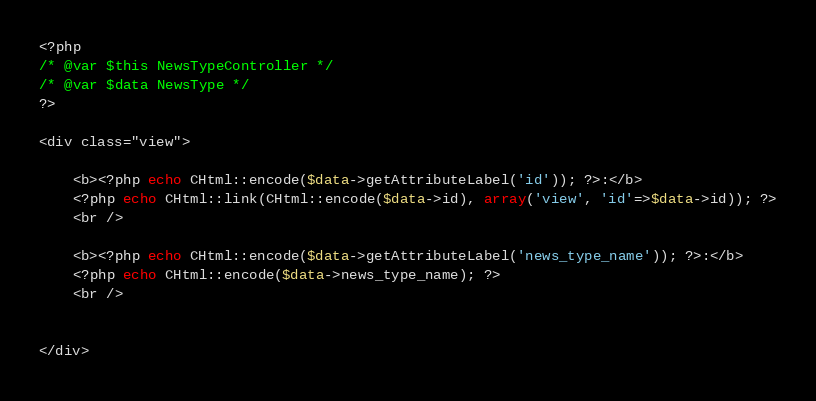<code> <loc_0><loc_0><loc_500><loc_500><_PHP_><?php
/* @var $this NewsTypeController */
/* @var $data NewsType */
?>

<div class="view">

	<b><?php echo CHtml::encode($data->getAttributeLabel('id')); ?>:</b>
	<?php echo CHtml::link(CHtml::encode($data->id), array('view', 'id'=>$data->id)); ?>
	<br />

	<b><?php echo CHtml::encode($data->getAttributeLabel('news_type_name')); ?>:</b>
	<?php echo CHtml::encode($data->news_type_name); ?>
	<br />


</div></code> 